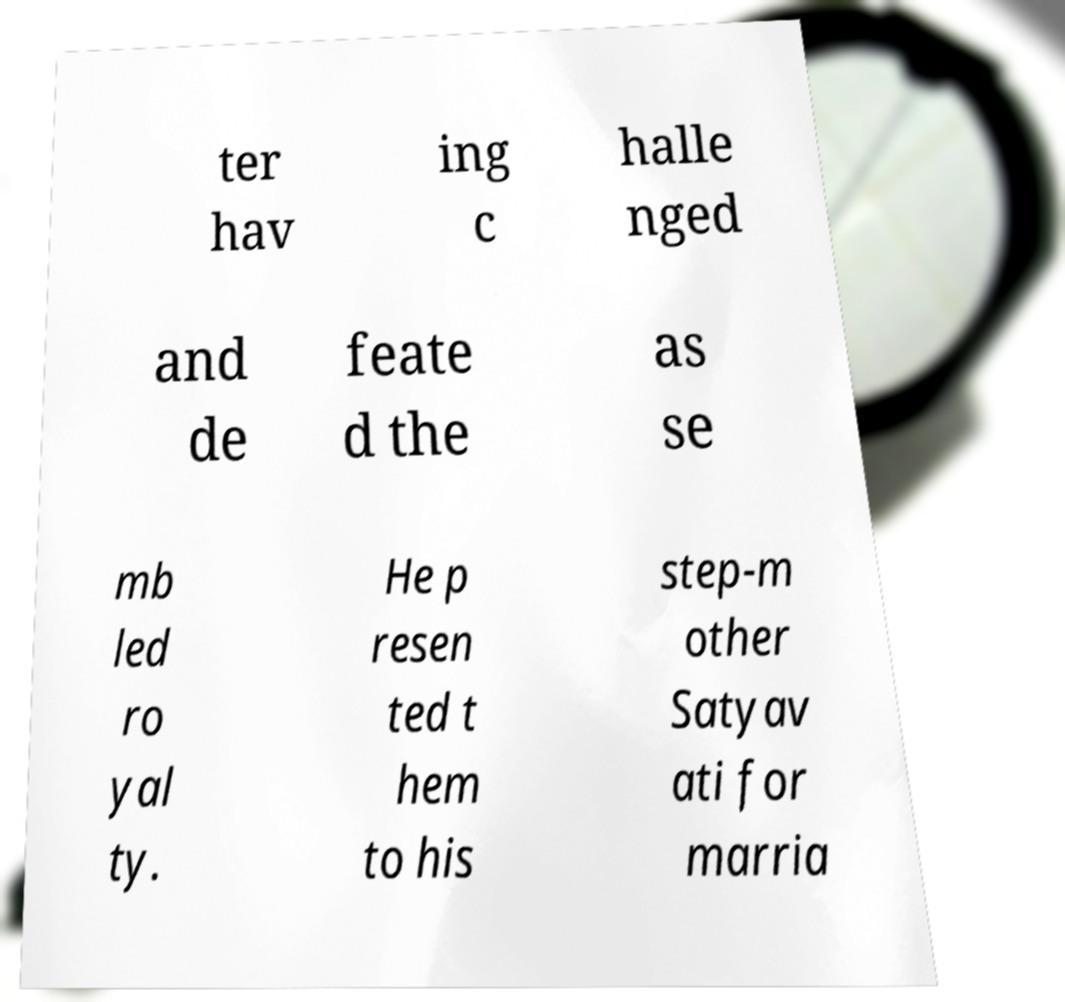Can you accurately transcribe the text from the provided image for me? ter hav ing c halle nged and de feate d the as se mb led ro yal ty. He p resen ted t hem to his step-m other Satyav ati for marria 